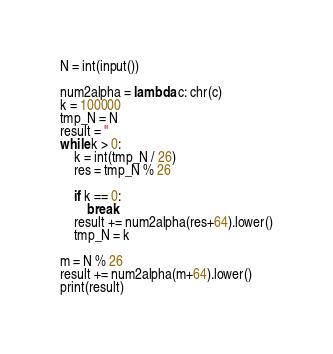Convert code to text. <code><loc_0><loc_0><loc_500><loc_500><_Python_>N = int(input())

num2alpha = lambda c: chr(c)
k = 100000
tmp_N = N
result = ''
while k > 0:
    k = int(tmp_N / 26)
    res = tmp_N % 26
        
    if k == 0:
        break
    result += num2alpha(res+64).lower()
    tmp_N = k

m = N % 26
result += num2alpha(m+64).lower()
print(result)</code> 